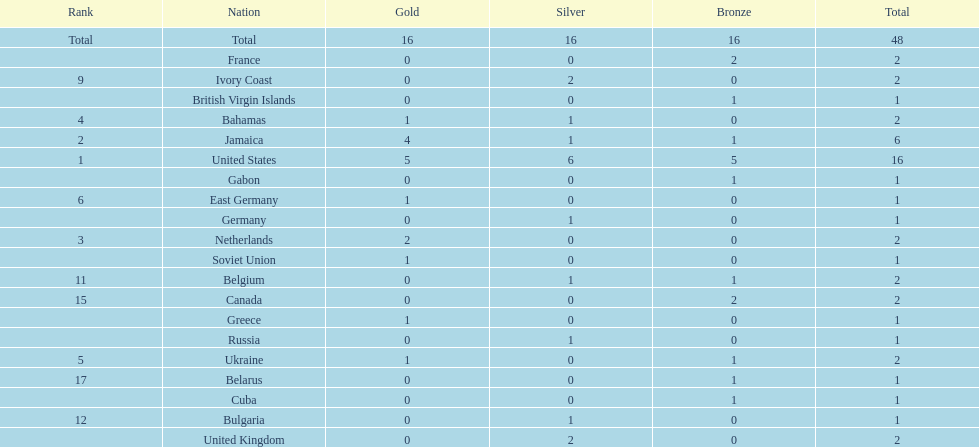What is the total number of gold medals won by jamaica? 4. 